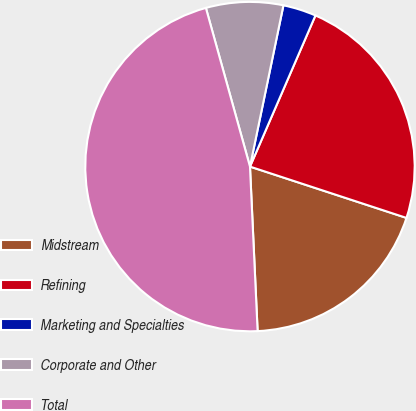Convert chart. <chart><loc_0><loc_0><loc_500><loc_500><pie_chart><fcel>Midstream<fcel>Refining<fcel>Marketing and Specialties<fcel>Corporate and Other<fcel>Total<nl><fcel>19.22%<fcel>23.54%<fcel>3.25%<fcel>7.57%<fcel>46.43%<nl></chart> 